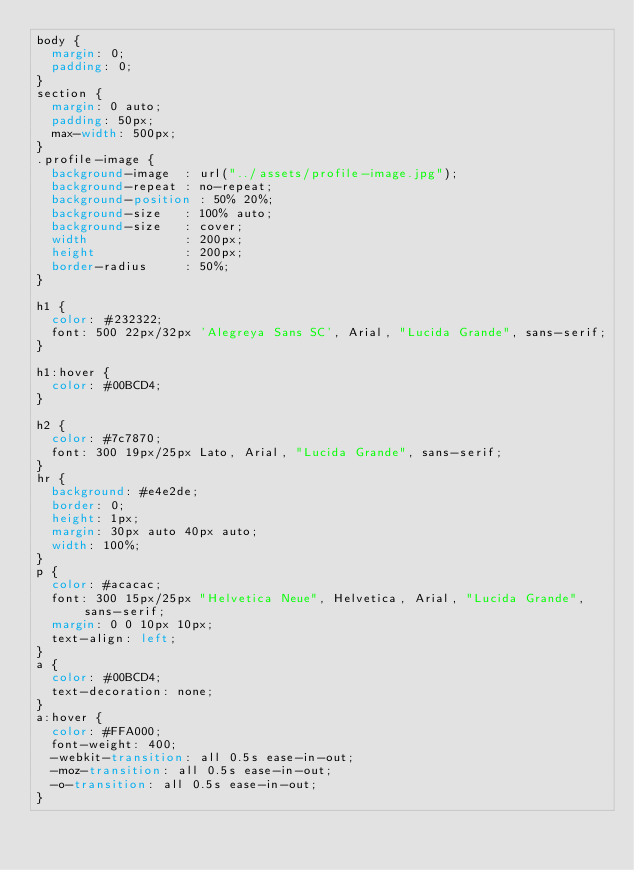Convert code to text. <code><loc_0><loc_0><loc_500><loc_500><_CSS_>body {
  margin: 0;
  padding: 0;
}
section {
  margin: 0 auto;
  padding: 50px;
  max-width: 500px;
}
.profile-image {
  background-image  : url("../assets/profile-image.jpg");
  background-repeat : no-repeat;
  background-position : 50% 20%;
  background-size   : 100% auto;
  background-size   : cover;
  width             : 200px;
  height            : 200px;
  border-radius     : 50%;
}

h1 {
  color: #232322;
  font: 500 22px/32px 'Alegreya Sans SC', Arial, "Lucida Grande", sans-serif;
}

h1:hover {
  color: #00BCD4;
}

h2 {
  color: #7c7870;
  font: 300 19px/25px Lato, Arial, "Lucida Grande", sans-serif;
}
hr {
  background: #e4e2de;
  border: 0;
  height: 1px;
  margin: 30px auto 40px auto;
  width: 100%;
}
p {
  color: #acacac;
  font: 300 15px/25px "Helvetica Neue", Helvetica, Arial, "Lucida Grande", sans-serif;
  margin: 0 0 10px 10px;
  text-align: left;
}
a {
  color: #00BCD4;
  text-decoration: none;
}
a:hover {
  color: #FFA000;
  font-weight: 400;
  -webkit-transition: all 0.5s ease-in-out;
  -moz-transition: all 0.5s ease-in-out;
  -o-transition: all 0.5s ease-in-out;
}
</code> 